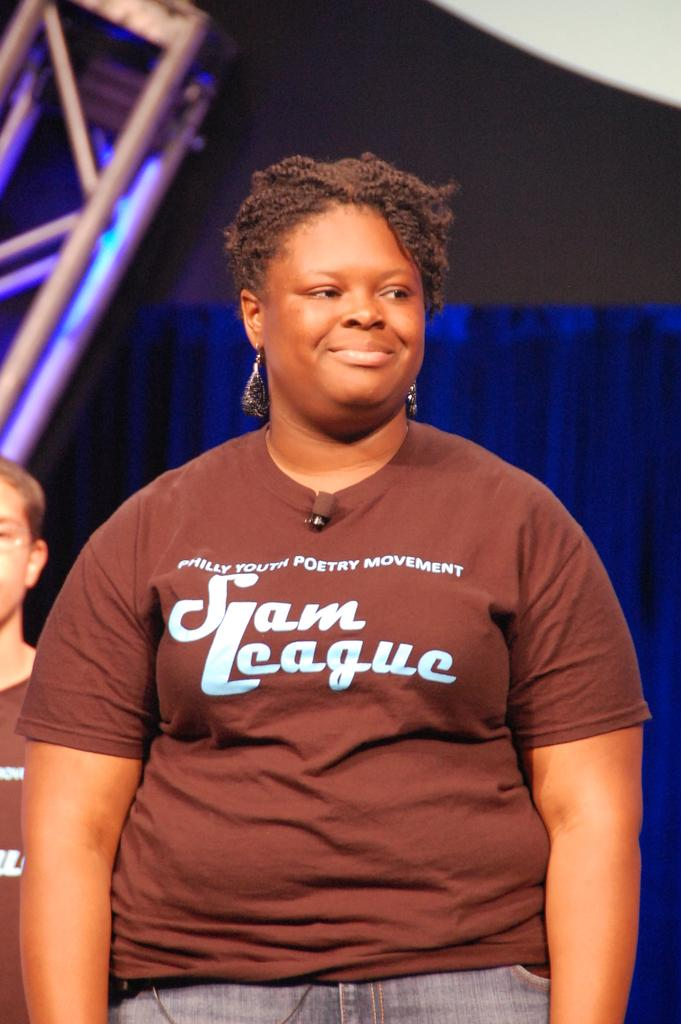<image>
Present a compact description of the photo's key features. A woman wearing a Philly Youth Poetry Movement top looks happy on the stage. 